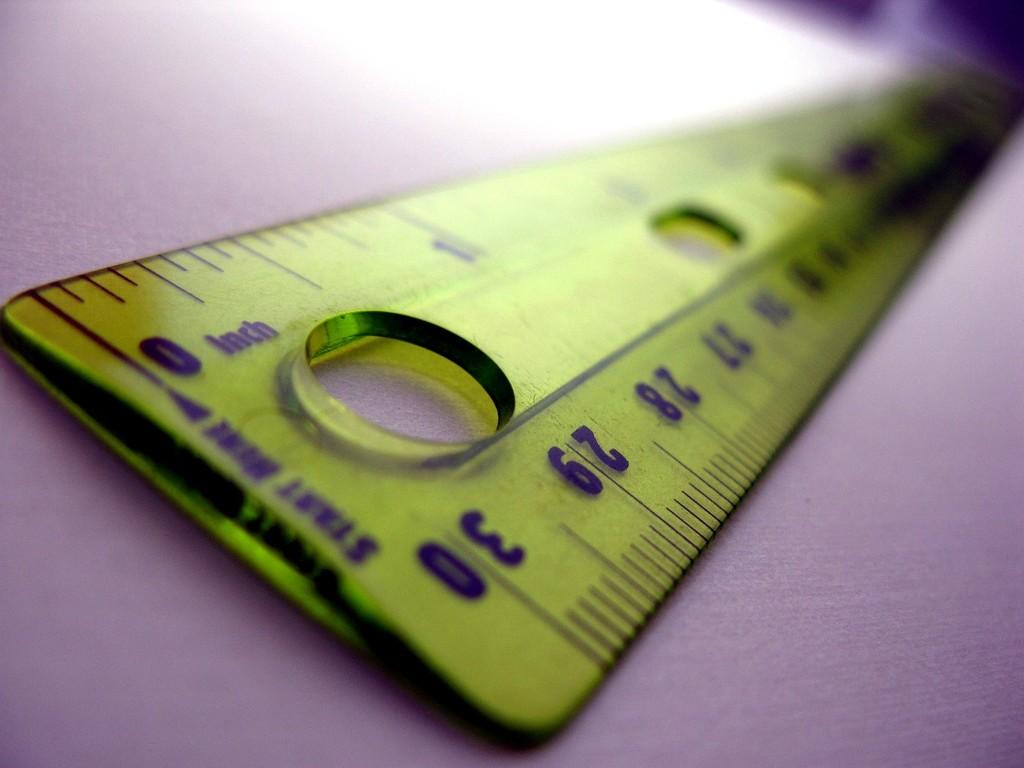In what imperial measurement is used on the top side of this ruler?
Your response must be concise. Inch. What is the highest number printed on this ruler?
Keep it short and to the point. 30. 